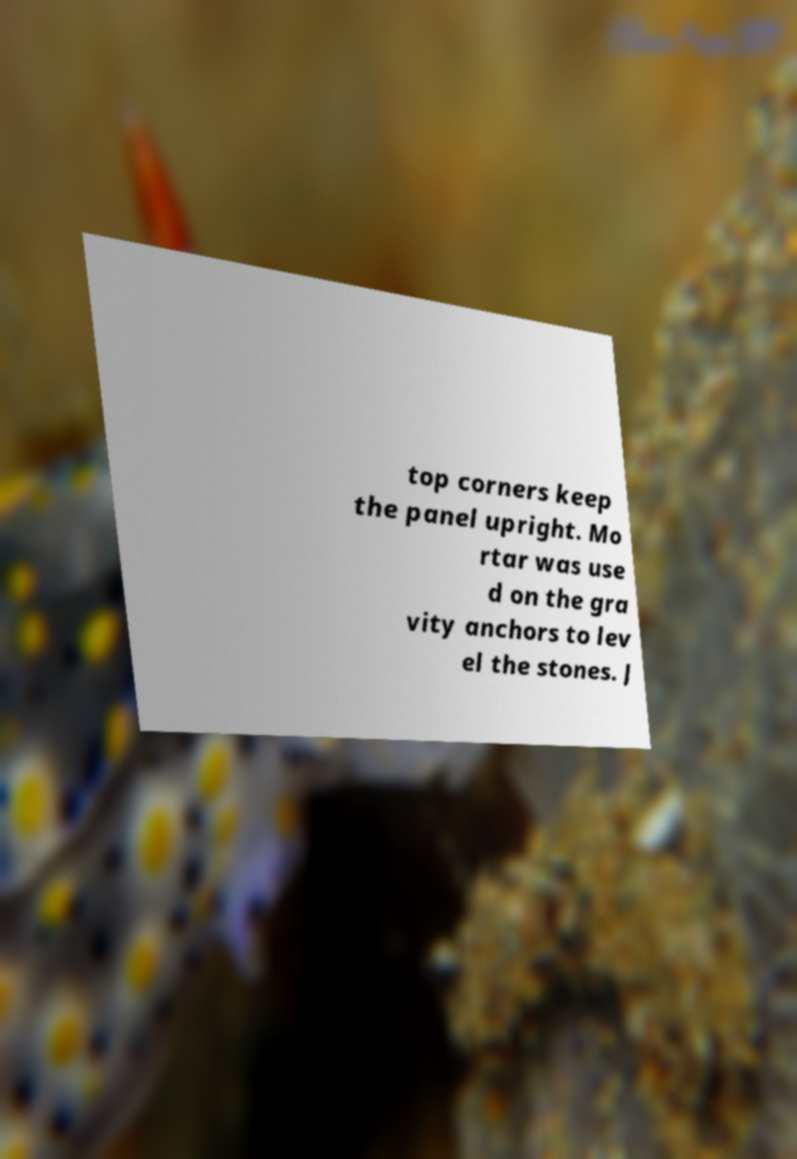Could you extract and type out the text from this image? top corners keep the panel upright. Mo rtar was use d on the gra vity anchors to lev el the stones. J 